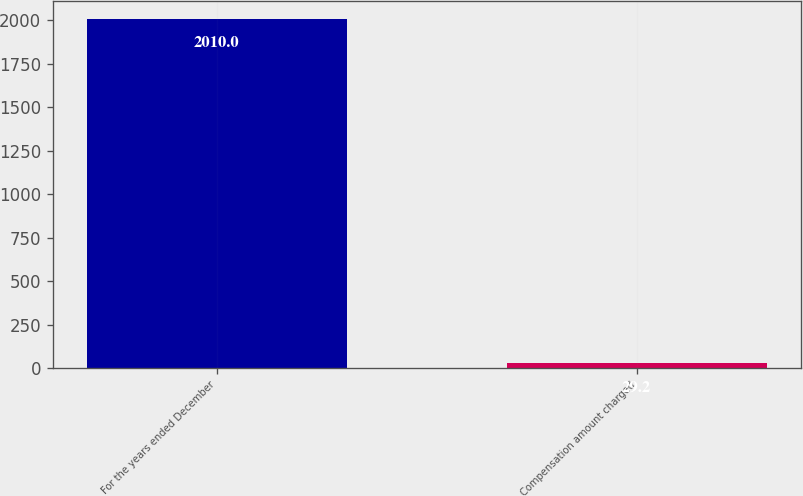<chart> <loc_0><loc_0><loc_500><loc_500><bar_chart><fcel>For the years ended December<fcel>Compensation amount charged<nl><fcel>2010<fcel>29.2<nl></chart> 